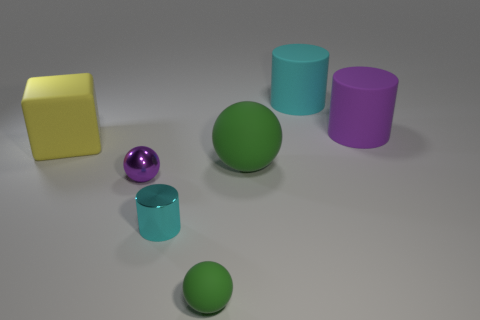Add 2 cyan matte cylinders. How many objects exist? 9 Subtract all cubes. How many objects are left? 6 Add 7 large purple objects. How many large purple objects exist? 8 Subtract 0 gray cubes. How many objects are left? 7 Subtract all large spheres. Subtract all small purple cylinders. How many objects are left? 6 Add 5 big green balls. How many big green balls are left? 6 